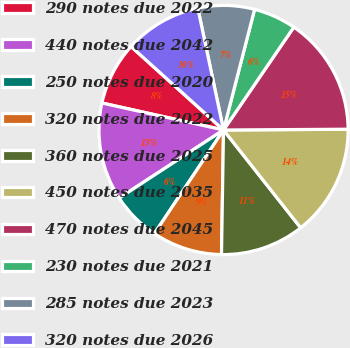<chart> <loc_0><loc_0><loc_500><loc_500><pie_chart><fcel>290 notes due 2022<fcel>440 notes due 2042<fcel>250 notes due 2020<fcel>320 notes due 2022<fcel>360 notes due 2025<fcel>450 notes due 2035<fcel>470 notes due 2045<fcel>230 notes due 2021<fcel>285 notes due 2023<fcel>320 notes due 2026<nl><fcel>8.21%<fcel>12.68%<fcel>6.43%<fcel>9.11%<fcel>10.89%<fcel>14.47%<fcel>15.36%<fcel>5.53%<fcel>7.32%<fcel>10.0%<nl></chart> 